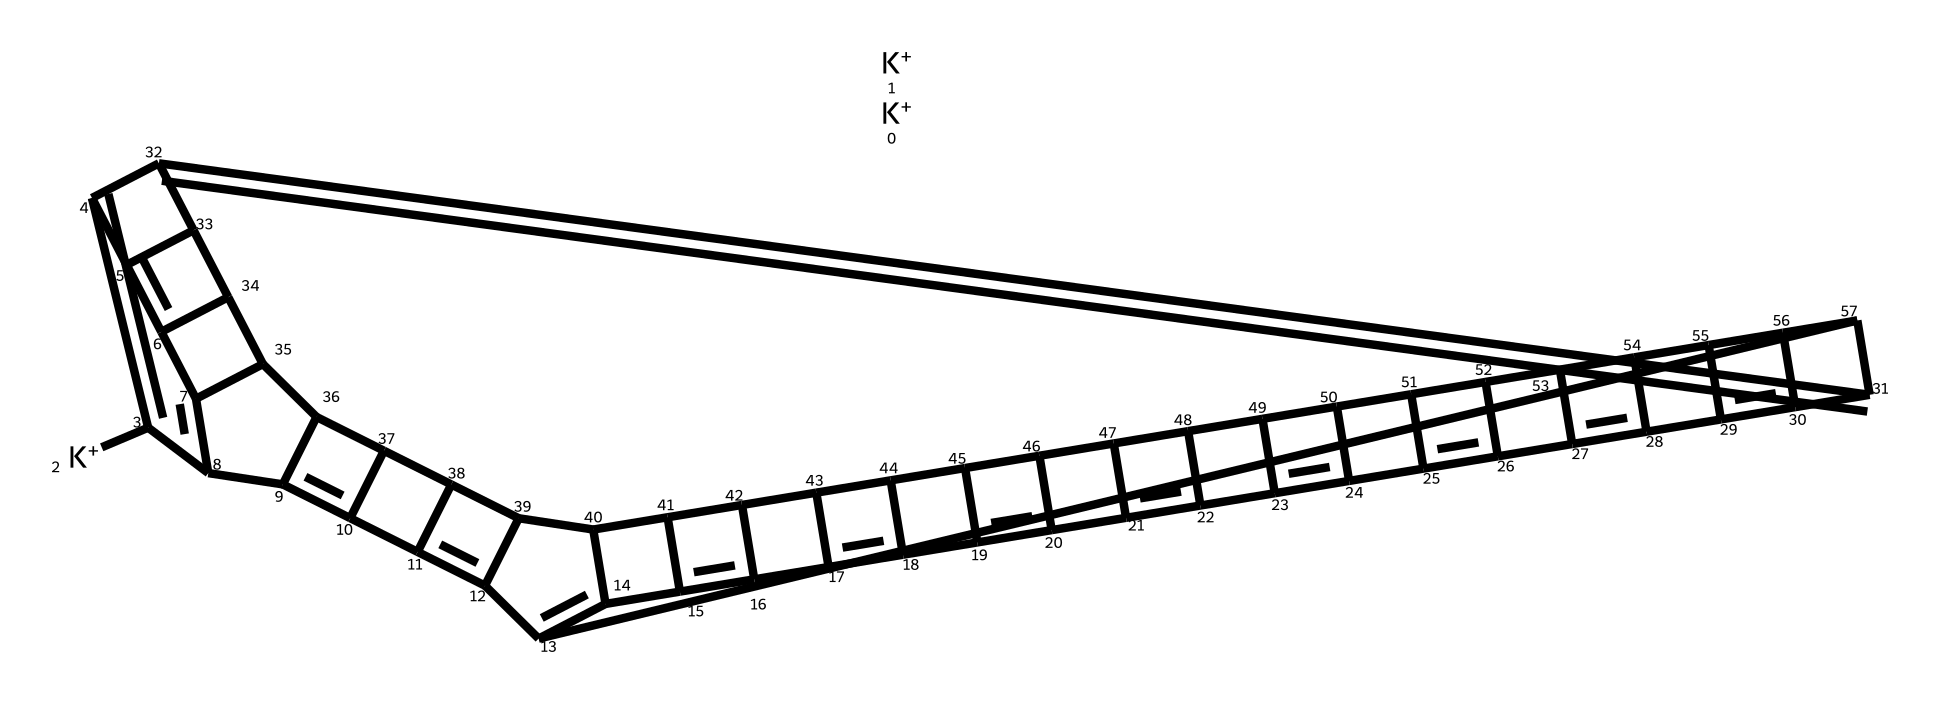What is the central atom in this molecular structure? The central atom in the structure of potassium-doped fullerides is carbon, as indicated by the presence of carbon atoms within the C(n) structure. Each carbon is part of the fullerene framework.
Answer: carbon How many potassium ions are there in this structure? By analyzing the SMILES notation, the presence of three '[K+]' units indicates there are three potassium ions in this fulleride structure.
Answer: three What type of bonding is primarily present in fullerides? Fullerides primarily exhibit covalent bonding. This can be determined by the arrangement of the carbon atoms that are interconnected via covalent bonds, forming a complex carbon structure.
Answer: covalent What is the total number of carbon atoms in this fulleride? The arrangement shows that there are a total of 60 carbon atoms in this structure, which can be counted based on the SMILES representation and the structure of fullerenes.
Answer: sixty How does potassium doping affect the properties of fullerides? Potassium doping introduces extra electrons that enhance conductivity and can enable superconductivity, significantly changing the electrical properties compared to pure fullerenes.
Answer: enhances conductivity What molecular geometry is exhibited by the carbon atoms in this structure? The carbon atoms in fullerides adopt a truncated icosahedral geometry, typical of fullerenes, characterized by vertices of pentagons and hexagons.
Answer: truncated icosahedral What kind of superconducting mechanism is associated with potassium-doped fullerides? The mechanism associated with potassium-doped fullerides is often described as electron-phonon coupling, where the doping increases the density of states at the Fermi level and contributes to superconductivity.
Answer: electron-phonon coupling 